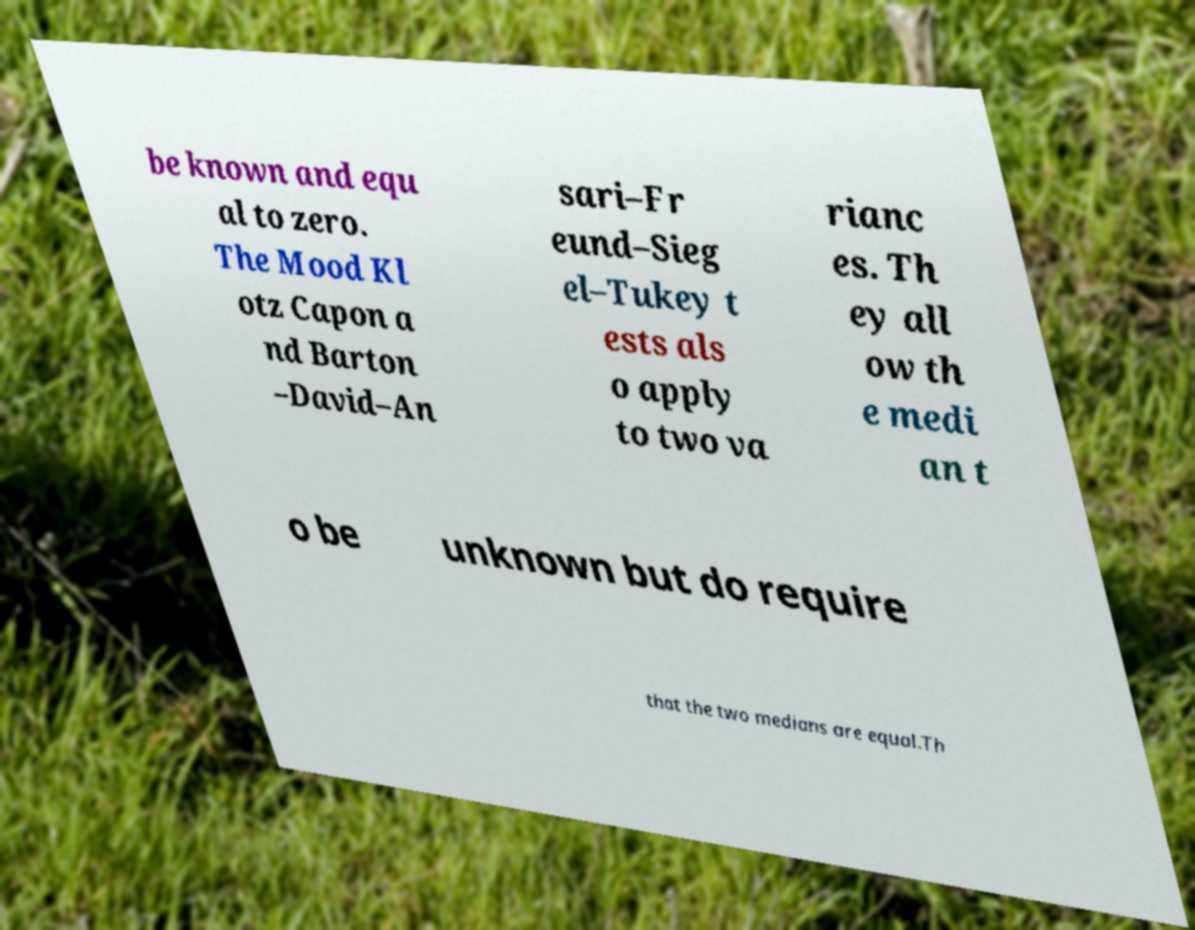For documentation purposes, I need the text within this image transcribed. Could you provide that? be known and equ al to zero. The Mood Kl otz Capon a nd Barton –David–An sari–Fr eund–Sieg el–Tukey t ests als o apply to two va rianc es. Th ey all ow th e medi an t o be unknown but do require that the two medians are equal.Th 